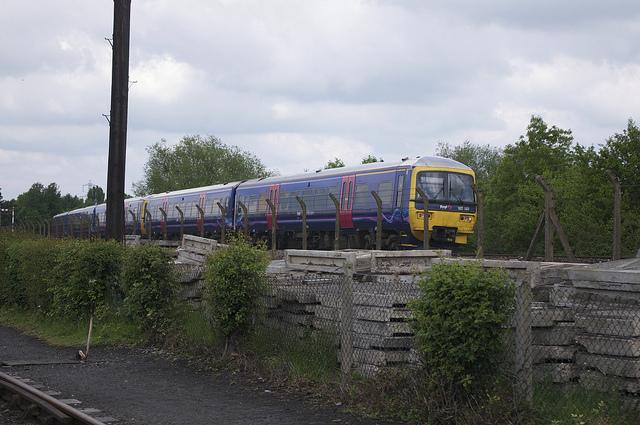Where is the train located?
Be succinct. Tracks. Is it wintertime?
Give a very brief answer. No. What color is the front of the train?
Quick response, please. Yellow. Is there water in the picture?
Write a very short answer. No. Is this train moving?
Concise answer only. Yes. What is on the left side of the train?
Short answer required. Fence. Is the train in motion?
Concise answer only. Yes. 